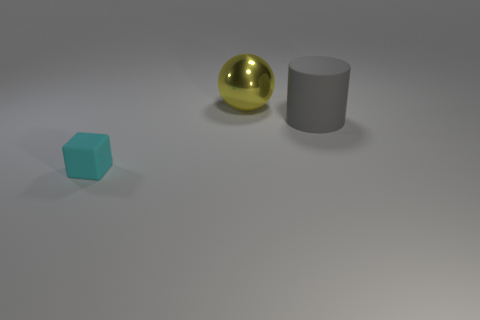Add 3 red metal cylinders. How many objects exist? 6 Subtract all balls. How many objects are left? 2 Add 1 big gray cylinders. How many big gray cylinders are left? 2 Add 2 small yellow metal balls. How many small yellow metal balls exist? 2 Subtract 0 red cylinders. How many objects are left? 3 Subtract all big balls. Subtract all metal spheres. How many objects are left? 1 